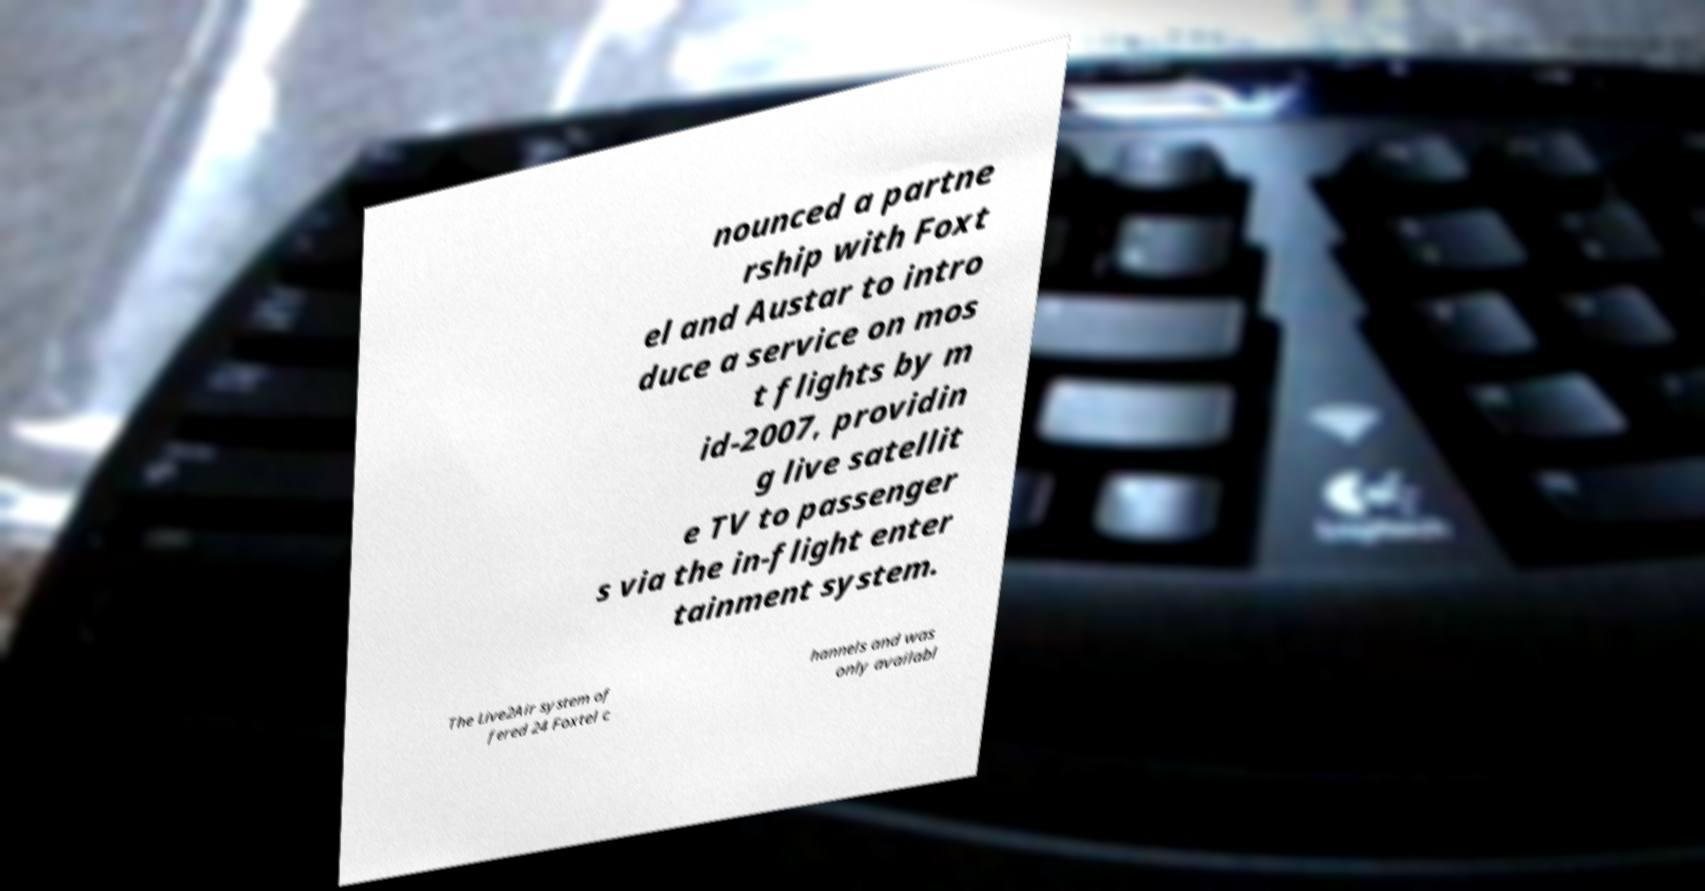Could you extract and type out the text from this image? nounced a partne rship with Foxt el and Austar to intro duce a service on mos t flights by m id-2007, providin g live satellit e TV to passenger s via the in-flight enter tainment system. The Live2Air system of fered 24 Foxtel c hannels and was only availabl 